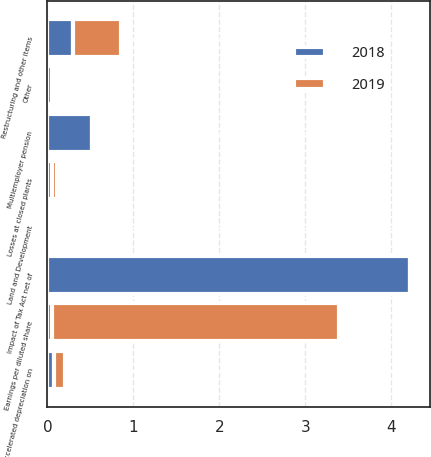<chart> <loc_0><loc_0><loc_500><loc_500><stacked_bar_chart><ecel><fcel>Earnings per diluted share<fcel>Restructuring and other items<fcel>Accelerated depreciation on<fcel>Losses at closed plants<fcel>Land and Development<fcel>Impact of Tax Act net of<fcel>Multiemployer pension<fcel>Other<nl><fcel>2019<fcel>3.33<fcel>0.56<fcel>0.12<fcel>0.05<fcel>0.03<fcel>0.02<fcel>0.01<fcel>0.01<nl><fcel>2018<fcel>0.06<fcel>0.3<fcel>0.08<fcel>0.06<fcel>0.02<fcel>4.22<fcel>0.52<fcel>0.05<nl></chart> 